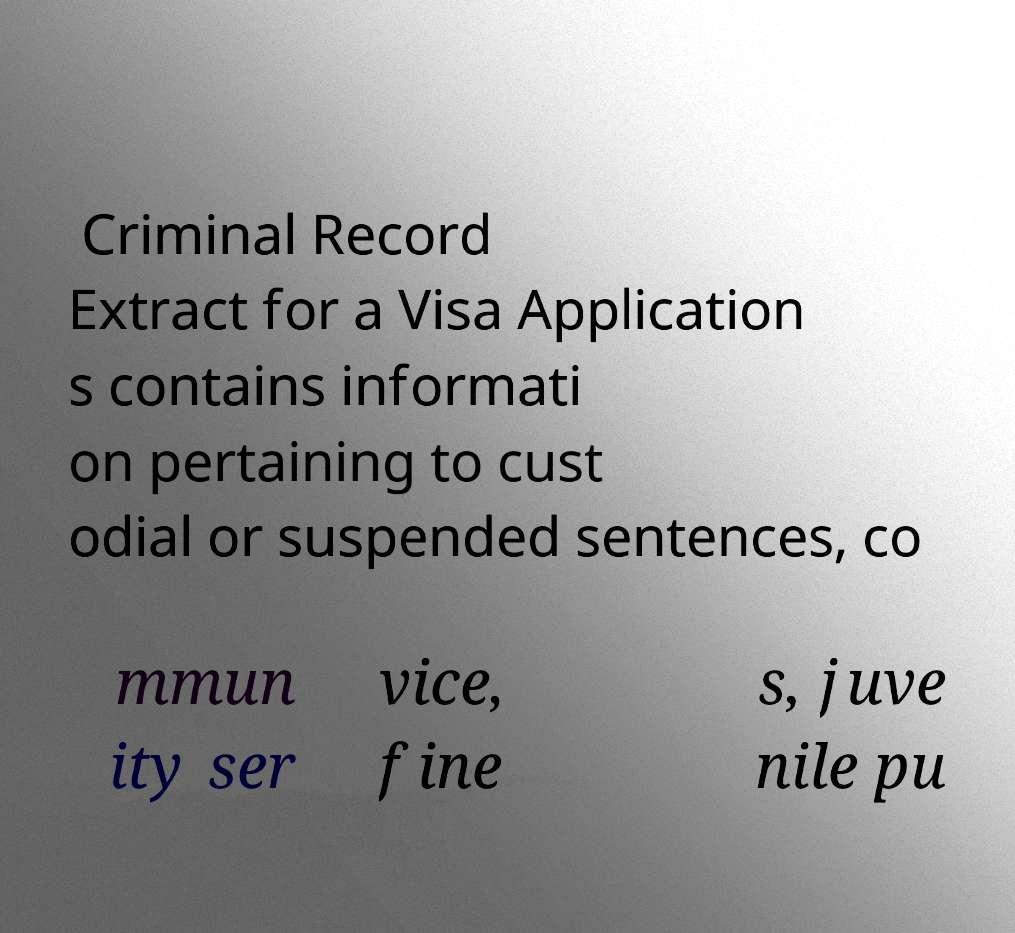For documentation purposes, I need the text within this image transcribed. Could you provide that? Criminal Record Extract for a Visa Application s contains informati on pertaining to cust odial or suspended sentences, co mmun ity ser vice, fine s, juve nile pu 